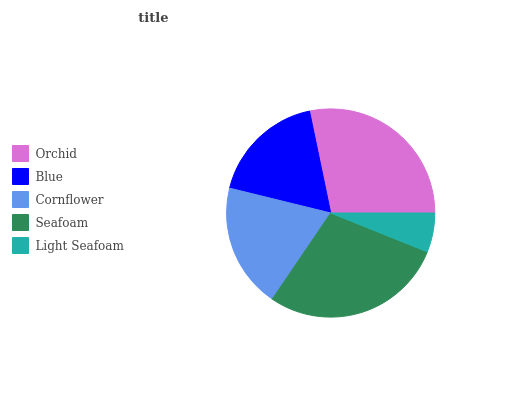Is Light Seafoam the minimum?
Answer yes or no. Yes. Is Seafoam the maximum?
Answer yes or no. Yes. Is Blue the minimum?
Answer yes or no. No. Is Blue the maximum?
Answer yes or no. No. Is Orchid greater than Blue?
Answer yes or no. Yes. Is Blue less than Orchid?
Answer yes or no. Yes. Is Blue greater than Orchid?
Answer yes or no. No. Is Orchid less than Blue?
Answer yes or no. No. Is Cornflower the high median?
Answer yes or no. Yes. Is Cornflower the low median?
Answer yes or no. Yes. Is Light Seafoam the high median?
Answer yes or no. No. Is Seafoam the low median?
Answer yes or no. No. 